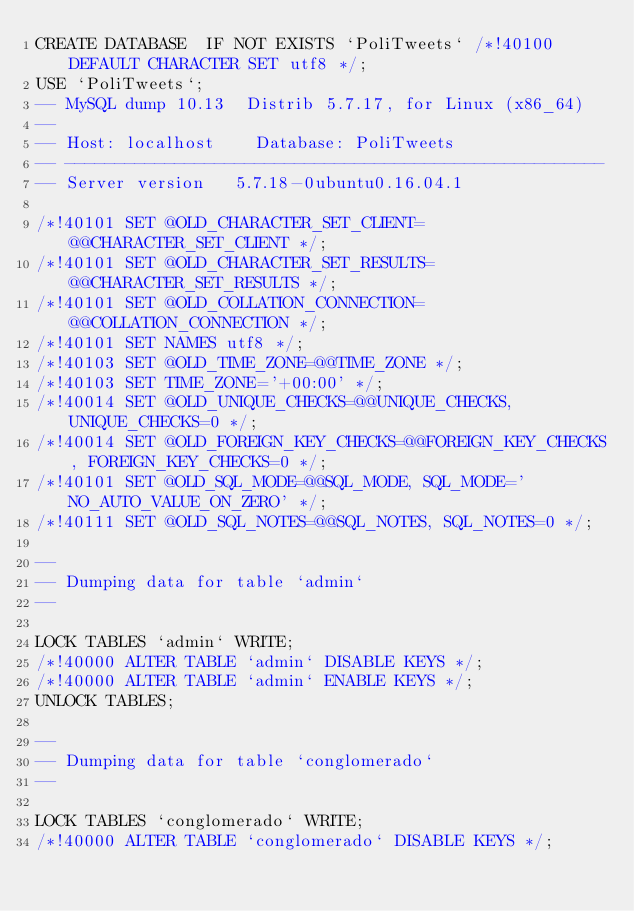Convert code to text. <code><loc_0><loc_0><loc_500><loc_500><_SQL_>CREATE DATABASE  IF NOT EXISTS `PoliTweets` /*!40100 DEFAULT CHARACTER SET utf8 */;
USE `PoliTweets`;
-- MySQL dump 10.13  Distrib 5.7.17, for Linux (x86_64)
--
-- Host: localhost    Database: PoliTweets
-- ------------------------------------------------------
-- Server version	5.7.18-0ubuntu0.16.04.1

/*!40101 SET @OLD_CHARACTER_SET_CLIENT=@@CHARACTER_SET_CLIENT */;
/*!40101 SET @OLD_CHARACTER_SET_RESULTS=@@CHARACTER_SET_RESULTS */;
/*!40101 SET @OLD_COLLATION_CONNECTION=@@COLLATION_CONNECTION */;
/*!40101 SET NAMES utf8 */;
/*!40103 SET @OLD_TIME_ZONE=@@TIME_ZONE */;
/*!40103 SET TIME_ZONE='+00:00' */;
/*!40014 SET @OLD_UNIQUE_CHECKS=@@UNIQUE_CHECKS, UNIQUE_CHECKS=0 */;
/*!40014 SET @OLD_FOREIGN_KEY_CHECKS=@@FOREIGN_KEY_CHECKS, FOREIGN_KEY_CHECKS=0 */;
/*!40101 SET @OLD_SQL_MODE=@@SQL_MODE, SQL_MODE='NO_AUTO_VALUE_ON_ZERO' */;
/*!40111 SET @OLD_SQL_NOTES=@@SQL_NOTES, SQL_NOTES=0 */;

--
-- Dumping data for table `admin`
--

LOCK TABLES `admin` WRITE;
/*!40000 ALTER TABLE `admin` DISABLE KEYS */;
/*!40000 ALTER TABLE `admin` ENABLE KEYS */;
UNLOCK TABLES;

--
-- Dumping data for table `conglomerado`
--

LOCK TABLES `conglomerado` WRITE;
/*!40000 ALTER TABLE `conglomerado` DISABLE KEYS */;</code> 